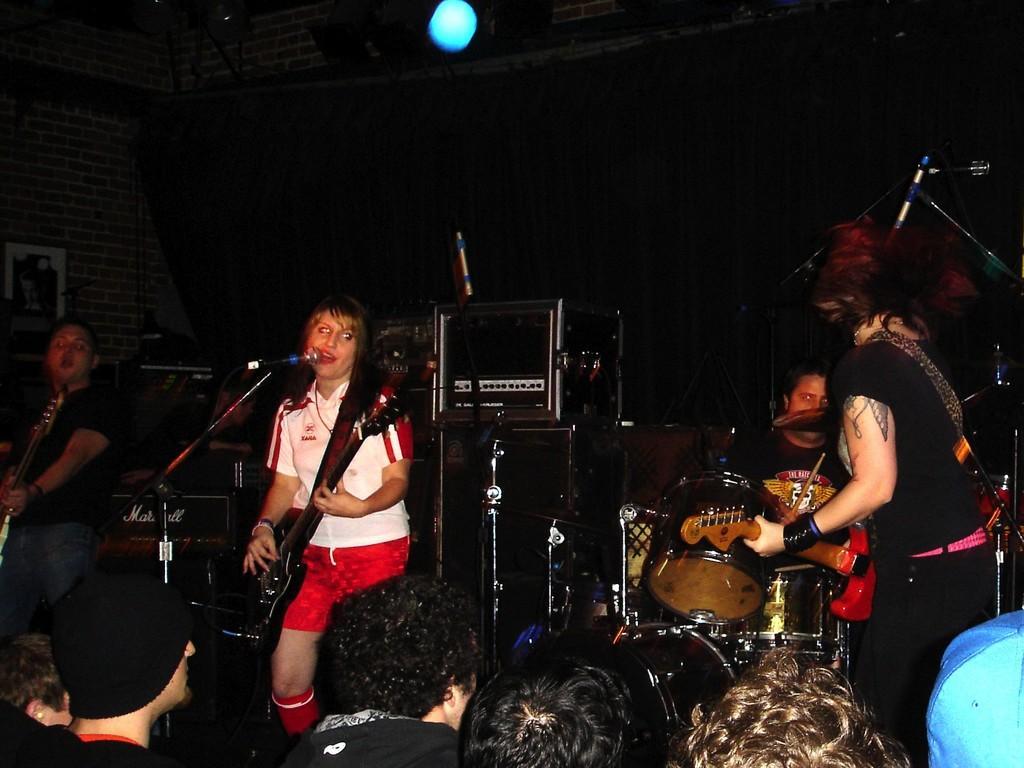Please provide a concise description of this image. This picture is clicked inside an auditorium. We can see many people sitting on the chairs and here we see, on the right corner of this picture, we see woman standing and playing guitar. Opposite of her, we can see man sitting and playing drums. To the left corner of this picture, we see a man holding guitar in his hands and playing. And in the middle of this picture, we see women wearing white and red t-shirt is catching guitar and playing it. She is even singing song on microphone. Behind them, we see a wall made of bricks and on the wall we see a photo frame. 